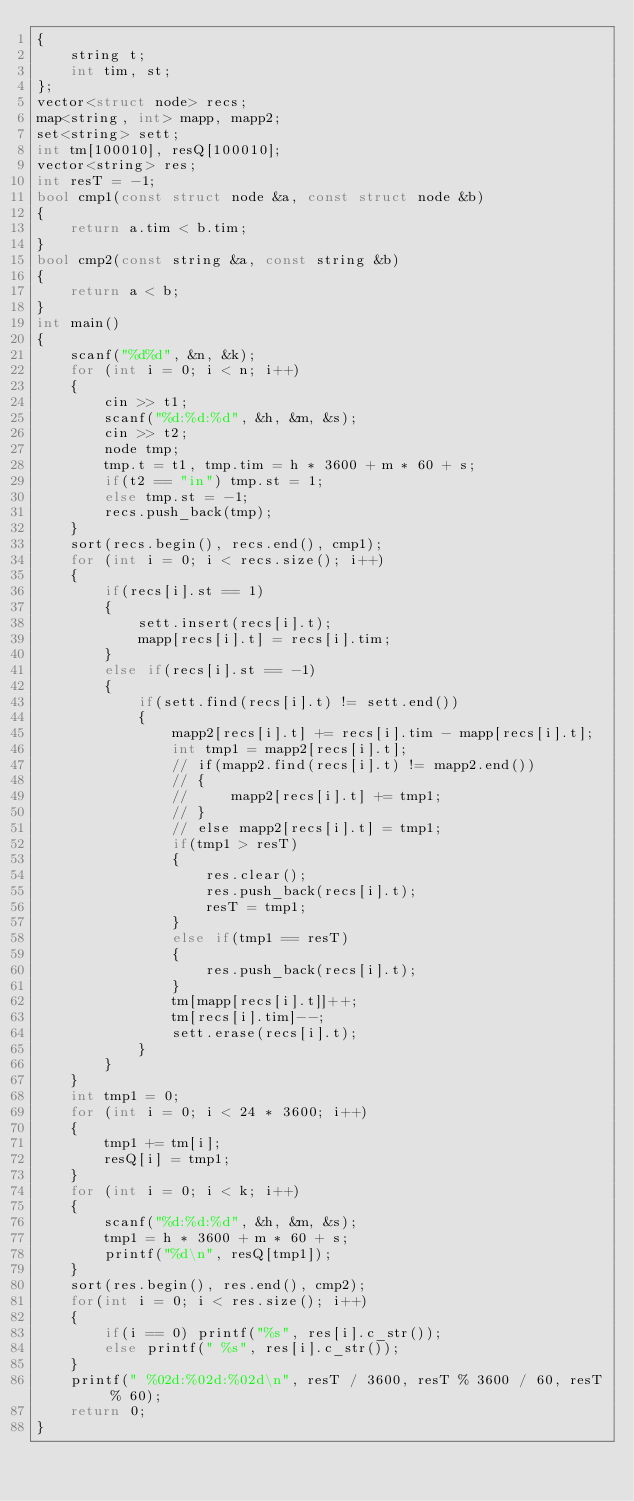Convert code to text. <code><loc_0><loc_0><loc_500><loc_500><_C++_>{
    string t;
    int tim, st;
};
vector<struct node> recs;
map<string, int> mapp, mapp2;
set<string> sett;
int tm[100010], resQ[100010];
vector<string> res;
int resT = -1;
bool cmp1(const struct node &a, const struct node &b)
{
    return a.tim < b.tim;
}
bool cmp2(const string &a, const string &b)
{
    return a < b;
}
int main()
{
    scanf("%d%d", &n, &k);
    for (int i = 0; i < n; i++)
    {
        cin >> t1;
        scanf("%d:%d:%d", &h, &m, &s);
        cin >> t2;
        node tmp;
        tmp.t = t1, tmp.tim = h * 3600 + m * 60 + s;
        if(t2 == "in") tmp.st = 1;
        else tmp.st = -1;
        recs.push_back(tmp);
    }
    sort(recs.begin(), recs.end(), cmp1);
    for (int i = 0; i < recs.size(); i++)
    {
        if(recs[i].st == 1)
        {
            sett.insert(recs[i].t);
            mapp[recs[i].t] = recs[i].tim;
        }
        else if(recs[i].st == -1)
        {
            if(sett.find(recs[i].t) != sett.end())
            {
                mapp2[recs[i].t] += recs[i].tim - mapp[recs[i].t];
                int tmp1 = mapp2[recs[i].t];
                // if(mapp2.find(recs[i].t) != mapp2.end())
                // {
                //     mapp2[recs[i].t] += tmp1;
                // }
                // else mapp2[recs[i].t] = tmp1;
                if(tmp1 > resT)
                {
                    res.clear();
                    res.push_back(recs[i].t);
                    resT = tmp1;
                }
                else if(tmp1 == resT)
                {
                    res.push_back(recs[i].t);
                }
                tm[mapp[recs[i].t]]++;
                tm[recs[i].tim]--;
                sett.erase(recs[i].t);
            }
        }
    }
    int tmp1 = 0;
    for (int i = 0; i < 24 * 3600; i++)
    {
        tmp1 += tm[i];
        resQ[i] = tmp1;
    }
    for (int i = 0; i < k; i++)
    {
        scanf("%d:%d:%d", &h, &m, &s);
        tmp1 = h * 3600 + m * 60 + s;
        printf("%d\n", resQ[tmp1]);
    }
    sort(res.begin(), res.end(), cmp2);
    for(int i = 0; i < res.size(); i++)
    {
        if(i == 0) printf("%s", res[i].c_str());
        else printf(" %s", res[i].c_str());
    }
    printf(" %02d:%02d:%02d\n", resT / 3600, resT % 3600 / 60, resT % 60);
    return 0;
}</code> 